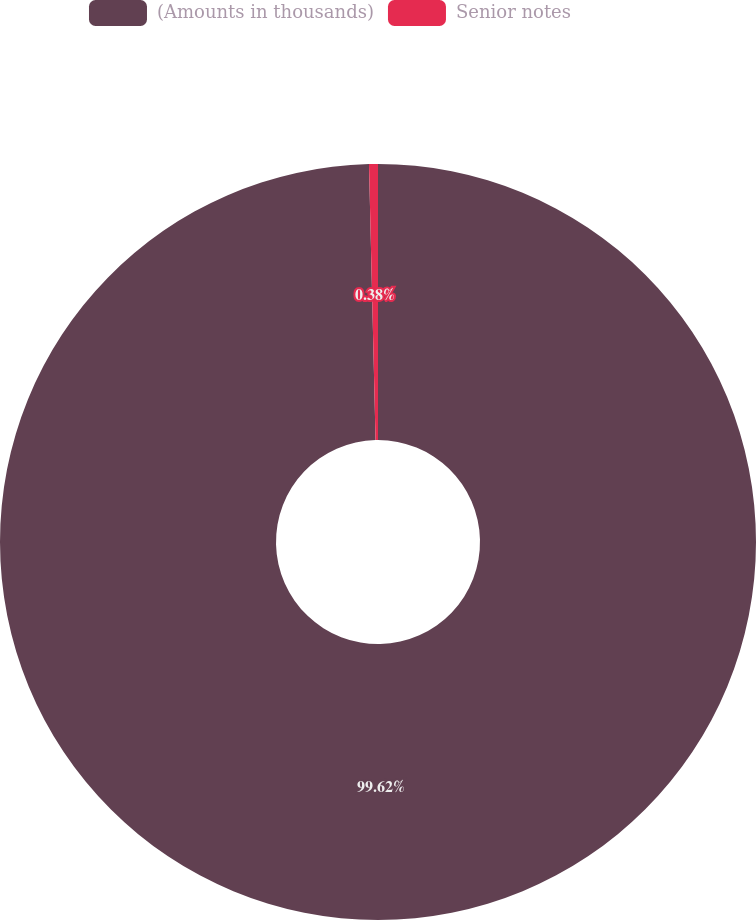<chart> <loc_0><loc_0><loc_500><loc_500><pie_chart><fcel>(Amounts in thousands)<fcel>Senior notes<nl><fcel>99.62%<fcel>0.38%<nl></chart> 